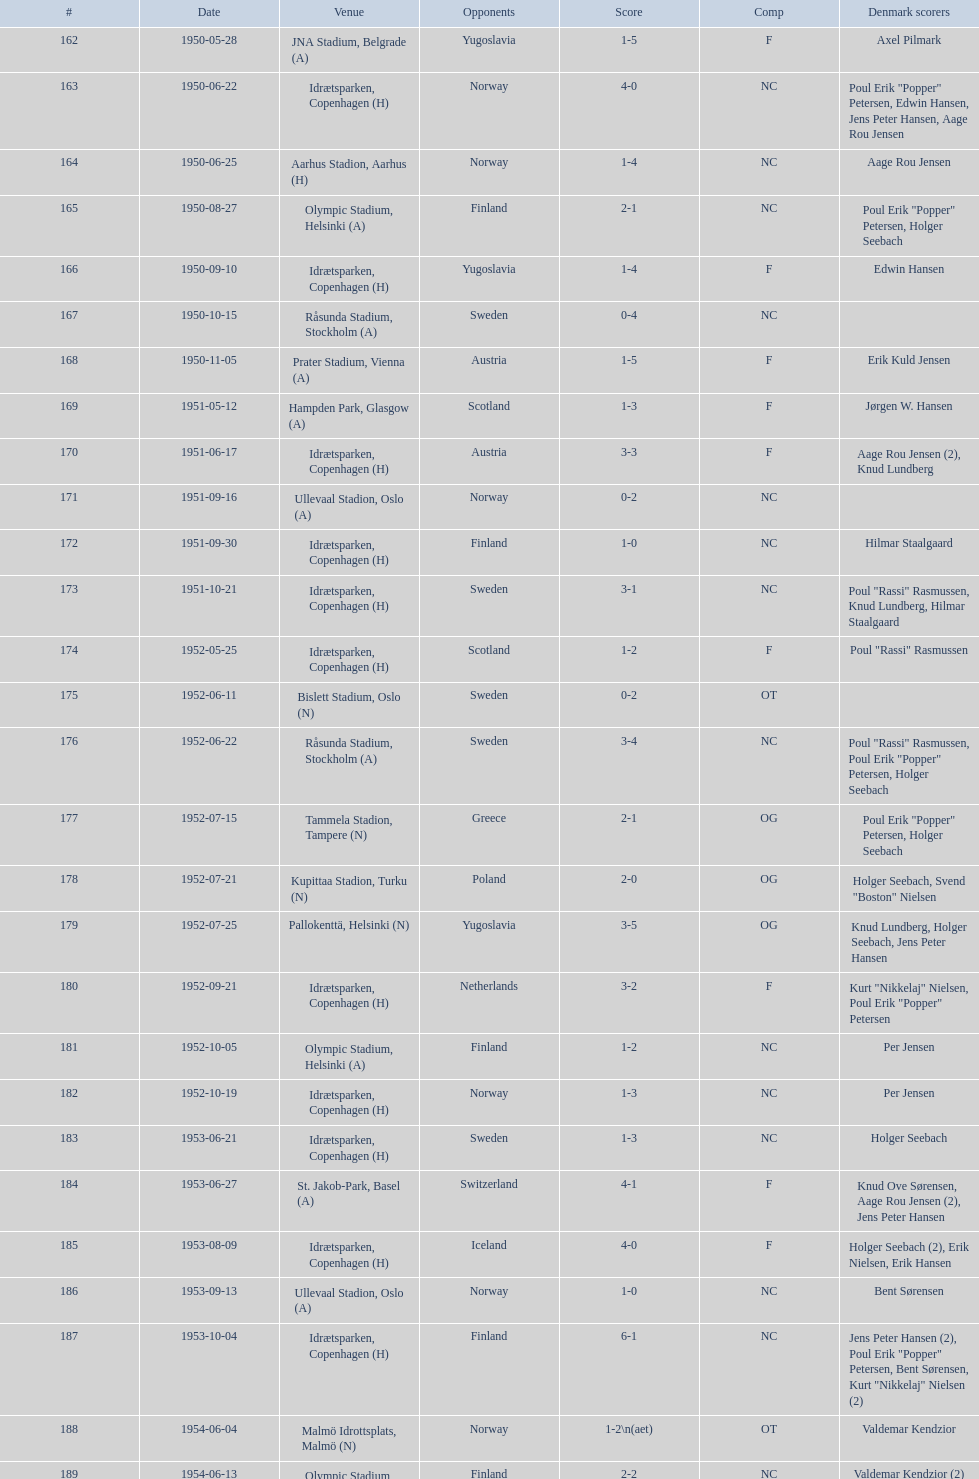What is the venue right below jna stadium, belgrade (a)? Idrætsparken, Copenhagen (H). Could you parse the entire table? {'header': ['#', 'Date', 'Venue', 'Opponents', 'Score', 'Comp', 'Denmark scorers'], 'rows': [['162', '1950-05-28', 'JNA Stadium, Belgrade (A)', 'Yugoslavia', '1-5', 'F', 'Axel Pilmark'], ['163', '1950-06-22', 'Idrætsparken, Copenhagen (H)', 'Norway', '4-0', 'NC', 'Poul Erik "Popper" Petersen, Edwin Hansen, Jens Peter Hansen, Aage Rou Jensen'], ['164', '1950-06-25', 'Aarhus Stadion, Aarhus (H)', 'Norway', '1-4', 'NC', 'Aage Rou Jensen'], ['165', '1950-08-27', 'Olympic Stadium, Helsinki (A)', 'Finland', '2-1', 'NC', 'Poul Erik "Popper" Petersen, Holger Seebach'], ['166', '1950-09-10', 'Idrætsparken, Copenhagen (H)', 'Yugoslavia', '1-4', 'F', 'Edwin Hansen'], ['167', '1950-10-15', 'Råsunda Stadium, Stockholm (A)', 'Sweden', '0-4', 'NC', ''], ['168', '1950-11-05', 'Prater Stadium, Vienna (A)', 'Austria', '1-5', 'F', 'Erik Kuld Jensen'], ['169', '1951-05-12', 'Hampden Park, Glasgow (A)', 'Scotland', '1-3', 'F', 'Jørgen W. Hansen'], ['170', '1951-06-17', 'Idrætsparken, Copenhagen (H)', 'Austria', '3-3', 'F', 'Aage Rou Jensen (2), Knud Lundberg'], ['171', '1951-09-16', 'Ullevaal Stadion, Oslo (A)', 'Norway', '0-2', 'NC', ''], ['172', '1951-09-30', 'Idrætsparken, Copenhagen (H)', 'Finland', '1-0', 'NC', 'Hilmar Staalgaard'], ['173', '1951-10-21', 'Idrætsparken, Copenhagen (H)', 'Sweden', '3-1', 'NC', 'Poul "Rassi" Rasmussen, Knud Lundberg, Hilmar Staalgaard'], ['174', '1952-05-25', 'Idrætsparken, Copenhagen (H)', 'Scotland', '1-2', 'F', 'Poul "Rassi" Rasmussen'], ['175', '1952-06-11', 'Bislett Stadium, Oslo (N)', 'Sweden', '0-2', 'OT', ''], ['176', '1952-06-22', 'Råsunda Stadium, Stockholm (A)', 'Sweden', '3-4', 'NC', 'Poul "Rassi" Rasmussen, Poul Erik "Popper" Petersen, Holger Seebach'], ['177', '1952-07-15', 'Tammela Stadion, Tampere (N)', 'Greece', '2-1', 'OG', 'Poul Erik "Popper" Petersen, Holger Seebach'], ['178', '1952-07-21', 'Kupittaa Stadion, Turku (N)', 'Poland', '2-0', 'OG', 'Holger Seebach, Svend "Boston" Nielsen'], ['179', '1952-07-25', 'Pallokenttä, Helsinki (N)', 'Yugoslavia', '3-5', 'OG', 'Knud Lundberg, Holger Seebach, Jens Peter Hansen'], ['180', '1952-09-21', 'Idrætsparken, Copenhagen (H)', 'Netherlands', '3-2', 'F', 'Kurt "Nikkelaj" Nielsen, Poul Erik "Popper" Petersen'], ['181', '1952-10-05', 'Olympic Stadium, Helsinki (A)', 'Finland', '1-2', 'NC', 'Per Jensen'], ['182', '1952-10-19', 'Idrætsparken, Copenhagen (H)', 'Norway', '1-3', 'NC', 'Per Jensen'], ['183', '1953-06-21', 'Idrætsparken, Copenhagen (H)', 'Sweden', '1-3', 'NC', 'Holger Seebach'], ['184', '1953-06-27', 'St. Jakob-Park, Basel (A)', 'Switzerland', '4-1', 'F', 'Knud Ove Sørensen, Aage Rou Jensen (2), Jens Peter Hansen'], ['185', '1953-08-09', 'Idrætsparken, Copenhagen (H)', 'Iceland', '4-0', 'F', 'Holger Seebach (2), Erik Nielsen, Erik Hansen'], ['186', '1953-09-13', 'Ullevaal Stadion, Oslo (A)', 'Norway', '1-0', 'NC', 'Bent Sørensen'], ['187', '1953-10-04', 'Idrætsparken, Copenhagen (H)', 'Finland', '6-1', 'NC', 'Jens Peter Hansen (2), Poul Erik "Popper" Petersen, Bent Sørensen, Kurt "Nikkelaj" Nielsen (2)'], ['188', '1954-06-04', 'Malmö Idrottsplats, Malmö (N)', 'Norway', '1-2\\n(aet)', 'OT', 'Valdemar Kendzior'], ['189', '1954-06-13', 'Olympic Stadium, Helsinki (A)', 'Finland', '2-2', 'NC', 'Valdemar Kendzior (2)'], ['190', '1954-09-19', 'Idrætsparken, Copenhagen (H)', 'Switzerland', '1-1', 'F', 'Jørgen Olesen'], ['191', '1954-10-10', 'Råsunda Stadium, Stockholm (A)', 'Sweden', '2-5', 'NC', 'Jens Peter Hansen, Bent Sørensen'], ['192', '1954-10-31', 'Idrætsparken, Copenhagen (H)', 'Norway', '0-1', 'NC', ''], ['193', '1955-03-13', 'Olympic Stadium, Amsterdam (A)', 'Netherlands', '1-1', 'F', 'Vagn Birkeland'], ['194', '1955-05-15', 'Idrætsparken, Copenhagen (H)', 'Hungary', '0-6', 'F', ''], ['195', '1955-06-19', 'Idrætsparken, Copenhagen (H)', 'Finland', '2-1', 'NC', 'Jens Peter Hansen (2)'], ['196', '1955-06-03', 'Melavollur, Reykjavík (A)', 'Iceland', '4-0', 'F', 'Aage Rou Jensen, Jens Peter Hansen, Poul Pedersen (2)'], ['197', '1955-09-11', 'Ullevaal Stadion, Oslo (A)', 'Norway', '1-1', 'NC', 'Jørgen Jacobsen'], ['198', '1955-10-02', 'Idrætsparken, Copenhagen (H)', 'England', '1-5', 'NC', 'Knud Lundberg'], ['199', '1955-10-16', 'Idrætsparken, Copenhagen (H)', 'Sweden', '3-3', 'NC', 'Ove Andersen (2), Knud Lundberg'], ['200', '1956-05-23', 'Dynamo Stadium, Moscow (A)', 'USSR', '1-5', 'F', 'Knud Lundberg'], ['201', '1956-06-24', 'Idrætsparken, Copenhagen (H)', 'Norway', '2-3', 'NC', 'Knud Lundberg, Poul Pedersen'], ['202', '1956-07-01', 'Idrætsparken, Copenhagen (H)', 'USSR', '2-5', 'F', 'Ove Andersen, Aage Rou Jensen'], ['203', '1956-09-16', 'Olympic Stadium, Helsinki (A)', 'Finland', '4-0', 'NC', 'Poul Pedersen, Jørgen Hansen, Ove Andersen (2)'], ['204', '1956-10-03', 'Dalymount Park, Dublin (A)', 'Republic of Ireland', '1-2', 'WCQ', 'Aage Rou Jensen'], ['205', '1956-10-21', 'Råsunda Stadium, Stockholm (A)', 'Sweden', '1-1', 'NC', 'Jens Peter Hansen'], ['206', '1956-11-04', 'Idrætsparken, Copenhagen (H)', 'Netherlands', '2-2', 'F', 'Jørgen Olesen, Knud Lundberg'], ['207', '1956-12-05', 'Molineux, Wolverhampton (A)', 'England', '2-5', 'WCQ', 'Ove Bech Nielsen (2)'], ['208', '1957-05-15', 'Idrætsparken, Copenhagen (H)', 'England', '1-4', 'WCQ', 'John Jensen'], ['209', '1957-05-26', 'Idrætsparken, Copenhagen (H)', 'Bulgaria', '1-1', 'F', 'Aage Rou Jensen'], ['210', '1957-06-18', 'Olympic Stadium, Helsinki (A)', 'Finland', '0-2', 'OT', ''], ['211', '1957-06-19', 'Tammela Stadion, Tampere (N)', 'Norway', '2-0', 'OT', 'Egon Jensen, Jørgen Hansen'], ['212', '1957-06-30', 'Idrætsparken, Copenhagen (H)', 'Sweden', '1-2', 'NC', 'Jens Peter Hansen'], ['213', '1957-07-10', 'Laugardalsvöllur, Reykjavík (A)', 'Iceland', '6-2', 'OT', 'Egon Jensen (3), Poul Pedersen, Jens Peter Hansen (2)'], ['214', '1957-09-22', 'Ullevaal Stadion, Oslo (A)', 'Norway', '2-2', 'NC', 'Poul Pedersen, Peder Kjær'], ['215', '1957-10-02', 'Idrætsparken, Copenhagen (H)', 'Republic of Ireland', '0-2', 'WCQ', ''], ['216', '1957-10-13', 'Idrætsparken, Copenhagen (H)', 'Finland', '3-0', 'NC', 'Finn Alfred Hansen, Ove Bech Nielsen, Mogens Machon'], ['217', '1958-05-15', 'Aarhus Stadion, Aarhus (H)', 'Curaçao', '3-2', 'F', 'Poul Pedersen, Henning Enoksen (2)'], ['218', '1958-05-25', 'Idrætsparken, Copenhagen (H)', 'Poland', '3-2', 'F', 'Jørn Sørensen, Poul Pedersen (2)'], ['219', '1958-06-29', 'Idrætsparken, Copenhagen (H)', 'Norway', '1-2', 'NC', 'Poul Pedersen'], ['220', '1958-09-14', 'Olympic Stadium, Helsinki (A)', 'Finland', '4-1', 'NC', 'Poul Pedersen, Mogens Machon, John Danielsen (2)'], ['221', '1958-09-24', 'Idrætsparken, Copenhagen (H)', 'West Germany', '1-1', 'F', 'Henning Enoksen'], ['222', '1958-10-15', 'Idrætsparken, Copenhagen (H)', 'Netherlands', '1-5', 'F', 'Henning Enoksen'], ['223', '1958-10-26', 'Råsunda Stadium, Stockholm (A)', 'Sweden', '4-4', 'NC', 'Ole Madsen (2), Henning Enoksen, Jørn Sørensen'], ['224', '1959-06-21', 'Idrætsparken, Copenhagen (H)', 'Sweden', '0-6', 'NC', ''], ['225', '1959-06-26', 'Laugardalsvöllur, Reykjavík (A)', 'Iceland', '4-2', 'OGQ', 'Jens Peter Hansen (2), Ole Madsen (2)'], ['226', '1959-07-02', 'Idrætsparken, Copenhagen (H)', 'Norway', '2-1', 'OGQ', 'Henning Enoksen, Ole Madsen'], ['227', '1959-08-18', 'Idrætsparken, Copenhagen (H)', 'Iceland', '1-1', 'OGQ', 'Henning Enoksen'], ['228', '1959-09-13', 'Ullevaal Stadion, Oslo (A)', 'Norway', '4-2', 'OGQ\\nNC', 'Harald Nielsen, Henning Enoksen (2), Poul Pedersen'], ['229', '1959-09-23', 'Idrætsparken, Copenhagen (H)', 'Czechoslovakia', '2-2', 'ENQ', 'Poul Pedersen, Bent Hansen'], ['230', '1959-10-04', 'Idrætsparken, Copenhagen (H)', 'Finland', '4-0', 'NC', 'Harald Nielsen (3), John Kramer'], ['231', '1959-10-18', 'Stadion Za Lužánkami, Brno (A)', 'Czechoslovakia', '1-5', 'ENQ', 'John Kramer'], ['232', '1959-12-02', 'Olympic Stadium, Athens (A)', 'Greece', '3-1', 'F', 'Henning Enoksen (2), Poul Pedersen'], ['233', '1959-12-06', 'Vasil Levski National Stadium, Sofia (A)', 'Bulgaria', '1-2', 'F', 'Henning Enoksen']]} 